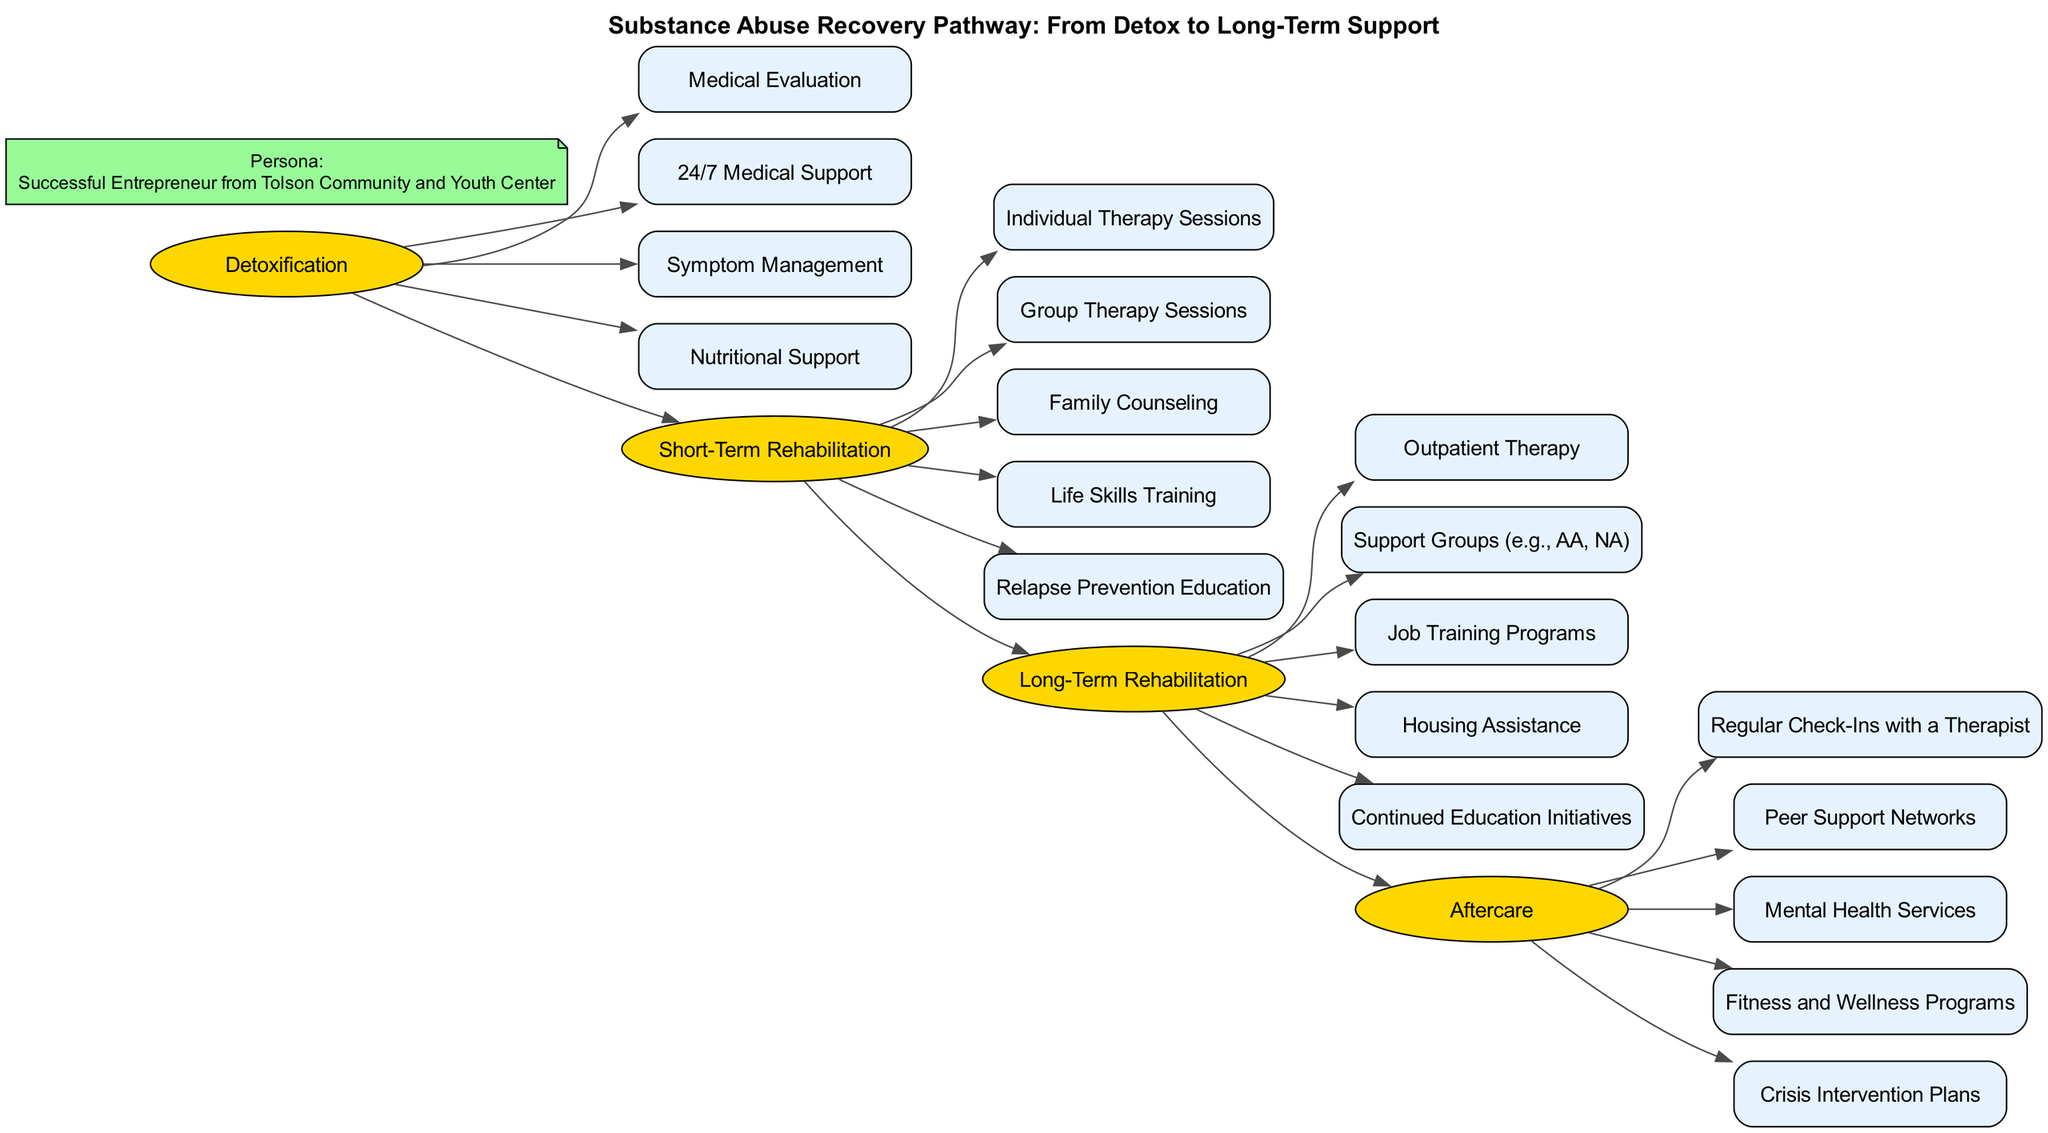What is the first phase in the recovery pathway? The diagram shows that the phases are arranged in a linear order from left to right, where the first phase listed is Detoxification.
Answer: Detoxification How many elements are there in Long-Term Rehabilitation? The Long-Term Rehabilitation phase contains five elements listed below it: Outpatient Therapy, Support Groups, Job Training Programs, Housing Assistance, Continued Education Initiatives. Thus, there are five elements.
Answer: 5 What type of therapy is included in Short-Term Rehabilitation? The Short-Term Rehabilitation phase contains three types of therapy: Individual Therapy Sessions, Group Therapy Sessions, and Family Counseling, which are direct responses to individual needs.
Answer: Individual, Group, Family Which phase directly follows Short-Term Rehabilitation? Following the Short-Term Rehabilitation phase, the next phase is Long-Term Rehabilitation, as indicated by the arrows connecting the phases in sequential order.
Answer: Long-Term Rehabilitation What support is provided during the Aftercare phase? The Aftercare phase includes multiple support services such as Regular Check-Ins with a Therapist, Peer Support Networks, Mental Health Services, Fitness and Wellness Programs, and Crisis Intervention Plans, indicating a comprehensive support structure.
Answer: Regular Check-Ins, Peer Support, Mental Health Services, Fitness and Wellness Programs, Crisis Intervention Plans How many phases are depicted in this pathway? The diagram displays four distinct phases in the recovery pathway: Detoxification, Short-Term Rehabilitation, Long-Term Rehabilitation, and Aftercare, enumerating the steps in the recovery journey.
Answer: 4 What is the role of Nutritional Support in Detoxification? Nutritional Support in the Detoxification phase is aimed at ensuring the physical health of individuals during the critical early stages of recovery, aiding their overall wellbeing.
Answer: Ensuring physical health Which phase includes Relapse Prevention Education? Relapse Prevention Education is featured in the Short-Term Rehabilitation phase, emphasizing its importance in equipping individuals with strategies to avoid relapse after treatment.
Answer: Short-Term Rehabilitation What is a key component of the Long-Term Rehabilitation phase? A significant component of the Long-Term Rehabilitation phase is Support Groups, which provide ongoing peer support essential for sustaining recovery.
Answer: Support Groups 